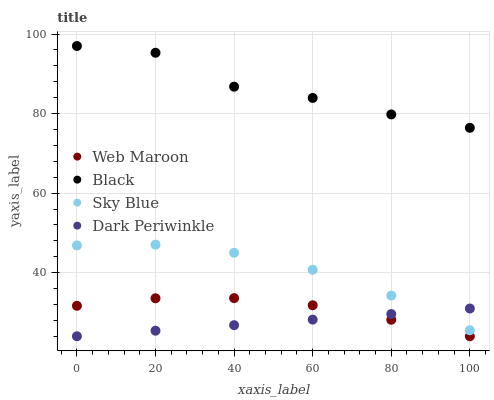Does Dark Periwinkle have the minimum area under the curve?
Answer yes or no. Yes. Does Black have the maximum area under the curve?
Answer yes or no. Yes. Does Web Maroon have the minimum area under the curve?
Answer yes or no. No. Does Web Maroon have the maximum area under the curve?
Answer yes or no. No. Is Dark Periwinkle the smoothest?
Answer yes or no. Yes. Is Black the roughest?
Answer yes or no. Yes. Is Web Maroon the smoothest?
Answer yes or no. No. Is Web Maroon the roughest?
Answer yes or no. No. Does Web Maroon have the lowest value?
Answer yes or no. Yes. Does Sky Blue have the lowest value?
Answer yes or no. No. Does Black have the highest value?
Answer yes or no. Yes. Does Web Maroon have the highest value?
Answer yes or no. No. Is Dark Periwinkle less than Black?
Answer yes or no. Yes. Is Black greater than Web Maroon?
Answer yes or no. Yes. Does Sky Blue intersect Dark Periwinkle?
Answer yes or no. Yes. Is Sky Blue less than Dark Periwinkle?
Answer yes or no. No. Is Sky Blue greater than Dark Periwinkle?
Answer yes or no. No. Does Dark Periwinkle intersect Black?
Answer yes or no. No. 